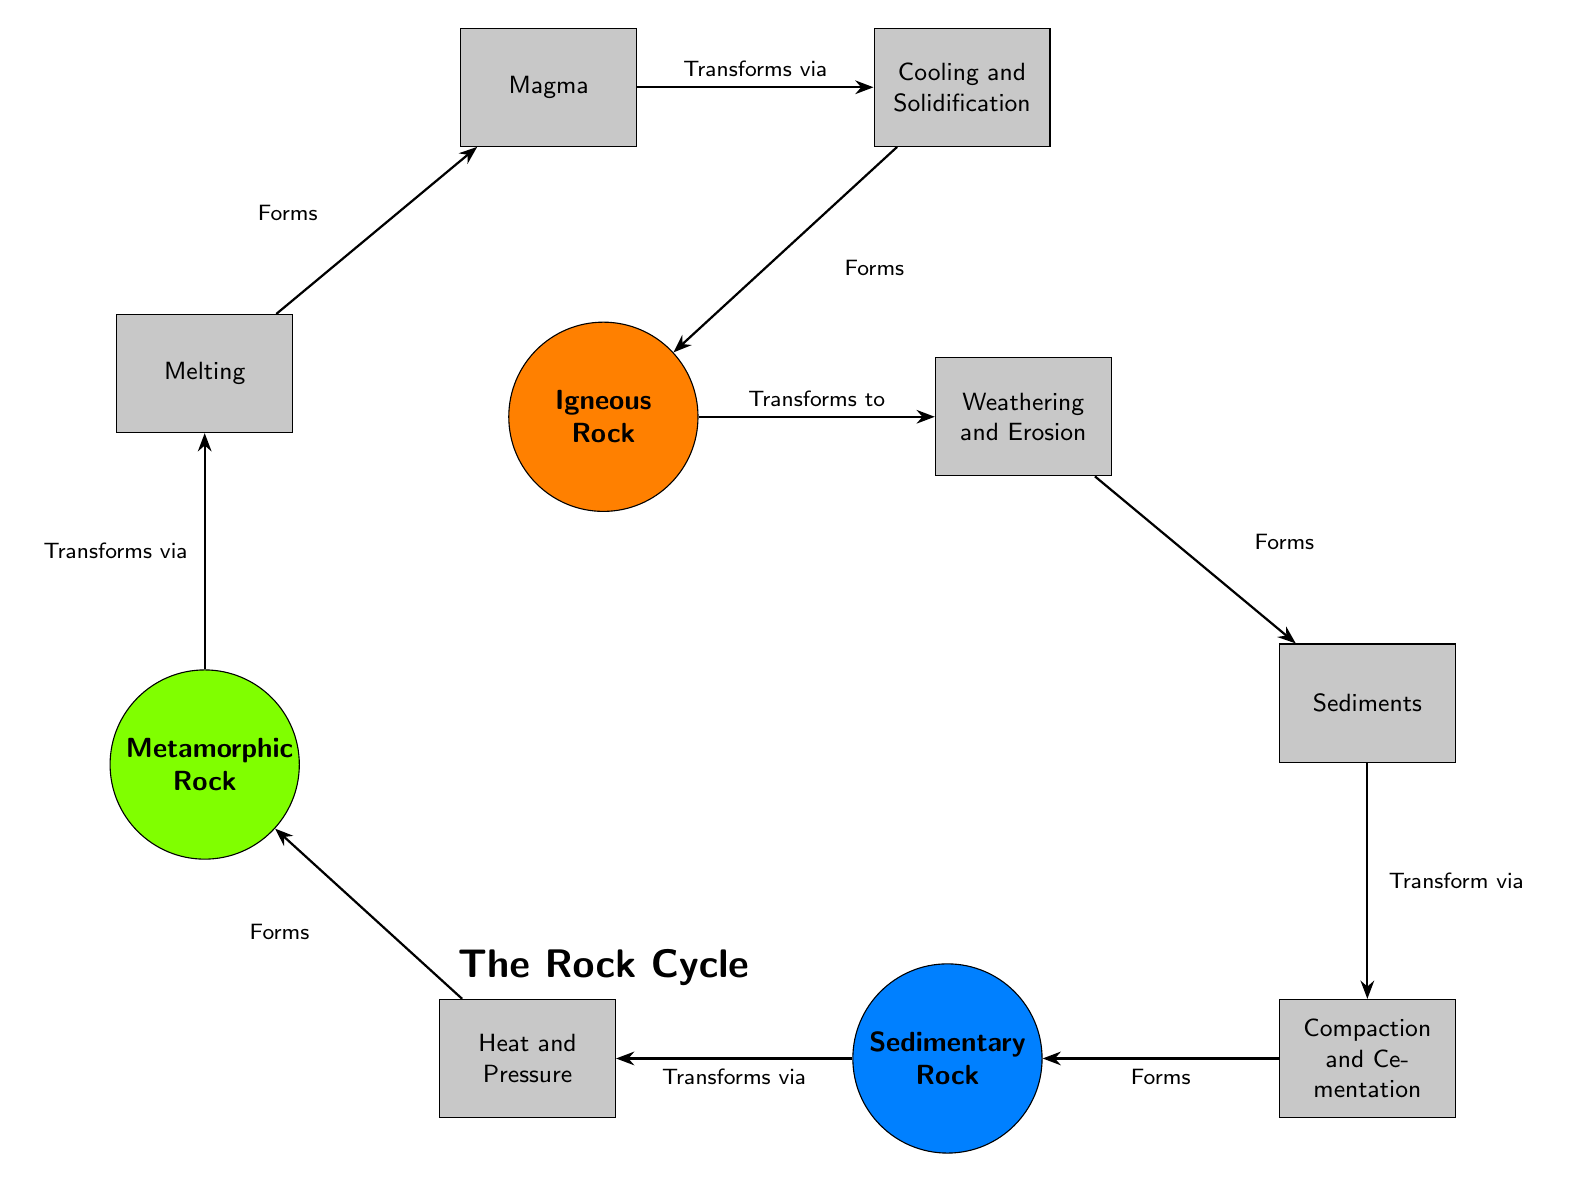What forms after weathering and erosion? The diagram indicates that after the igneous rock undergoes weathering and erosion, it transforms into sediments. This flow is represented by the arrow pointing from weathering to sediments.
Answer: Sediments How many types of rocks are shown in the diagram? The diagram illustrates three types of rocks: igneous, sedimentary, and metamorphic. This can be counted by looking at the labels of the circular nodes.
Answer: Three What process transforms sediment into sedimentary rock? According to the diagram, the process that transforms sediments into sedimentary rock is compaction and cementation, which is connected to the sediments by an arrow labeled "Transform via."
Answer: Compaction and Cementation What is located above the metamorphic rock? The diagram shows that above the metamorphic rock is the process of melting. This is identified by looking at the vertical arrangement of the nodes, where melting is directly positioned above metamorphic rock.
Answer: Melting Which rock transforms into magma? From the diagram, it can be observed that the rock which transforms into magma is the metamorphic rock, following the melting process represented by the arrow connecting them.
Answer: Metamorphic Rock What is the final stage of cooling in the rock cycle? The diagram indicates that the final stage of cooling is the formation of igneous rock after completed cooling and solidification. This is seen at the end of the cooling process in the diagram.
Answer: Igneous Rock What transforms magma into igneous rock? The process that transforms magma into igneous rock is cooling and solidification, as illustrated by the connecting arrow from magma leading to igneous rock.
Answer: Cooling and Solidification What transformation occurs from igneous rock to sediments? The transformation from igneous rock to sediments occurs through weathering and erosion, which is displayed by the directional arrow indicating that this process leads to the formation of sediments.
Answer: Weathering and Erosion 